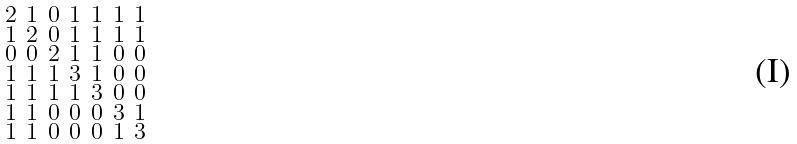Convert formula to latex. <formula><loc_0><loc_0><loc_500><loc_500>\begin{smallmatrix} 2 & 1 & 0 & 1 & 1 & 1 & 1 \\ 1 & 2 & 0 & 1 & 1 & 1 & 1 \\ 0 & 0 & 2 & 1 & 1 & 0 & 0 \\ 1 & 1 & 1 & 3 & 1 & 0 & 0 \\ 1 & 1 & 1 & 1 & 3 & 0 & 0 \\ 1 & 1 & 0 & 0 & 0 & 3 & 1 \\ 1 & 1 & 0 & 0 & 0 & 1 & 3 \end{smallmatrix}</formula> 